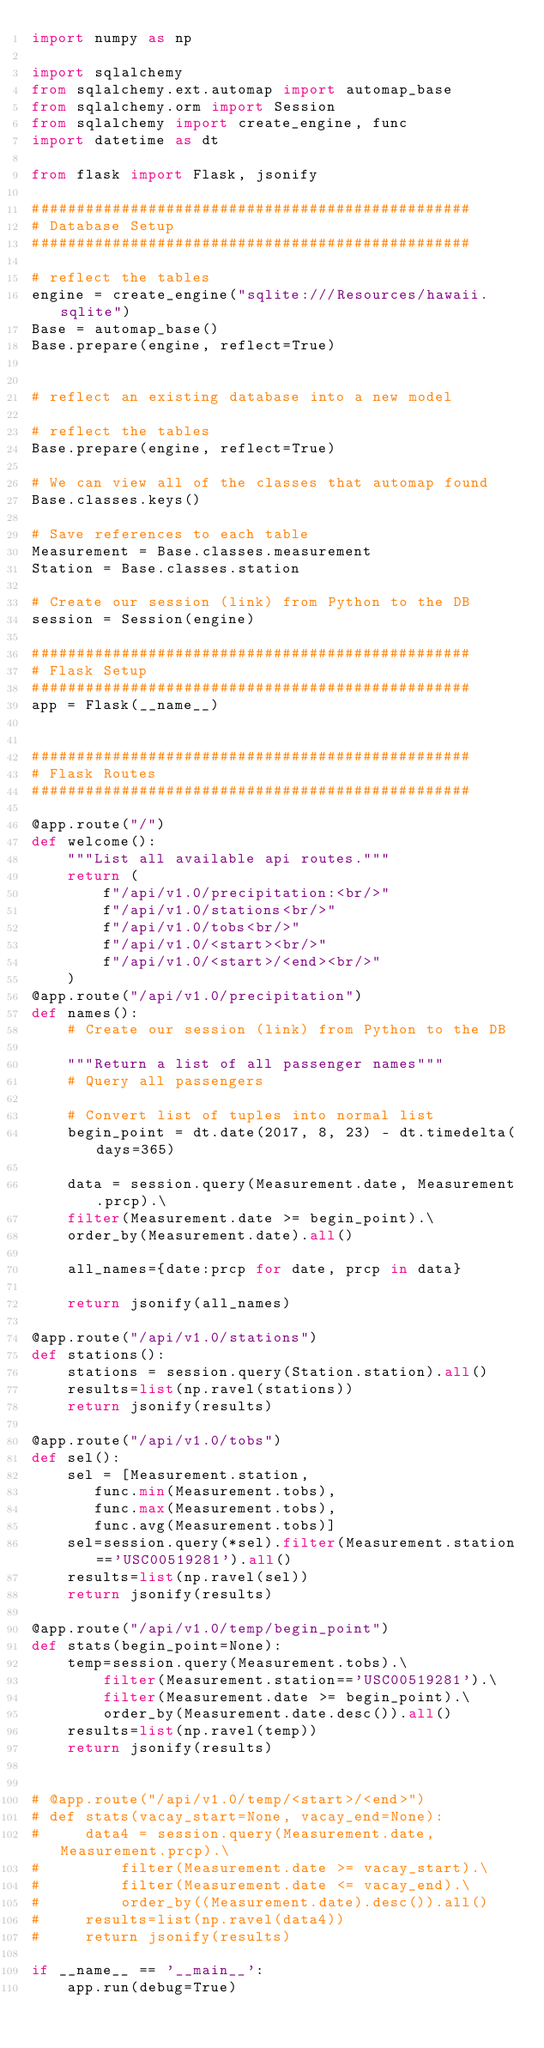Convert code to text. <code><loc_0><loc_0><loc_500><loc_500><_Python_>import numpy as np

import sqlalchemy
from sqlalchemy.ext.automap import automap_base
from sqlalchemy.orm import Session
from sqlalchemy import create_engine, func
import datetime as dt

from flask import Flask, jsonify

#################################################
# Database Setup
#################################################

# reflect the tables
engine = create_engine("sqlite:///Resources/hawaii.sqlite")
Base = automap_base()
Base.prepare(engine, reflect=True)


# reflect an existing database into a new model

# reflect the tables
Base.prepare(engine, reflect=True)

# We can view all of the classes that automap found
Base.classes.keys()

# Save references to each table
Measurement = Base.classes.measurement
Station = Base.classes.station

# Create our session (link) from Python to the DB
session = Session(engine)

#################################################
# Flask Setup
#################################################
app = Flask(__name__)


#################################################
# Flask Routes
#################################################

@app.route("/")
def welcome():
    """List all available api routes."""
    return (
        f"/api/v1.0/precipitation:<br/>"
        f"/api/v1.0/stations<br/>"
        f"/api/v1.0/tobs<br/>"
        f"/api/v1.0/<start><br/>"
        f"/api/v1.0/<start>/<end><br/>"
    )
@app.route("/api/v1.0/precipitation")
def names():
    # Create our session (link) from Python to the DB

    """Return a list of all passenger names"""
    # Query all passengers

    # Convert list of tuples into normal list
    begin_point = dt.date(2017, 8, 23) - dt.timedelta(days=365)
    
    data = session.query(Measurement.date, Measurement.prcp).\
    filter(Measurement.date >= begin_point).\
    order_by(Measurement.date).all()

    all_names={date:prcp for date, prcp in data}

    return jsonify(all_names)

@app.route("/api/v1.0/stations")
def stations():
    stations = session.query(Station.station).all()
    results=list(np.ravel(stations))
    return jsonify(results)

@app.route("/api/v1.0/tobs")
def sel():
    sel = [Measurement.station, 
       func.min(Measurement.tobs), 
       func.max(Measurement.tobs), 
       func.avg(Measurement.tobs)]
    sel=session.query(*sel).filter(Measurement.station=='USC00519281').all()
    results=list(np.ravel(sel))
    return jsonify(results)

@app.route("/api/v1.0/temp/begin_point")
def stats(begin_point=None):
    temp=session.query(Measurement.tobs).\
        filter(Measurement.station=='USC00519281').\
        filter(Measurement.date >= begin_point).\
        order_by(Measurement.date.desc()).all()
    results=list(np.ravel(temp))
    return jsonify(results)


# @app.route("/api/v1.0/temp/<start>/<end>")
# def stats(vacay_start=None, vacay_end=None):
#     data4 = session.query(Measurement.date, Measurement.prcp).\
#         filter(Measurement.date >= vacay_start).\
#         filter(Measurement.date <= vacay_end).\
#         order_by((Measurement.date).desc()).all()
#     results=list(np.ravel(data4))
#     return jsonify(results)

if __name__ == '__main__':
    app.run(debug=True)</code> 